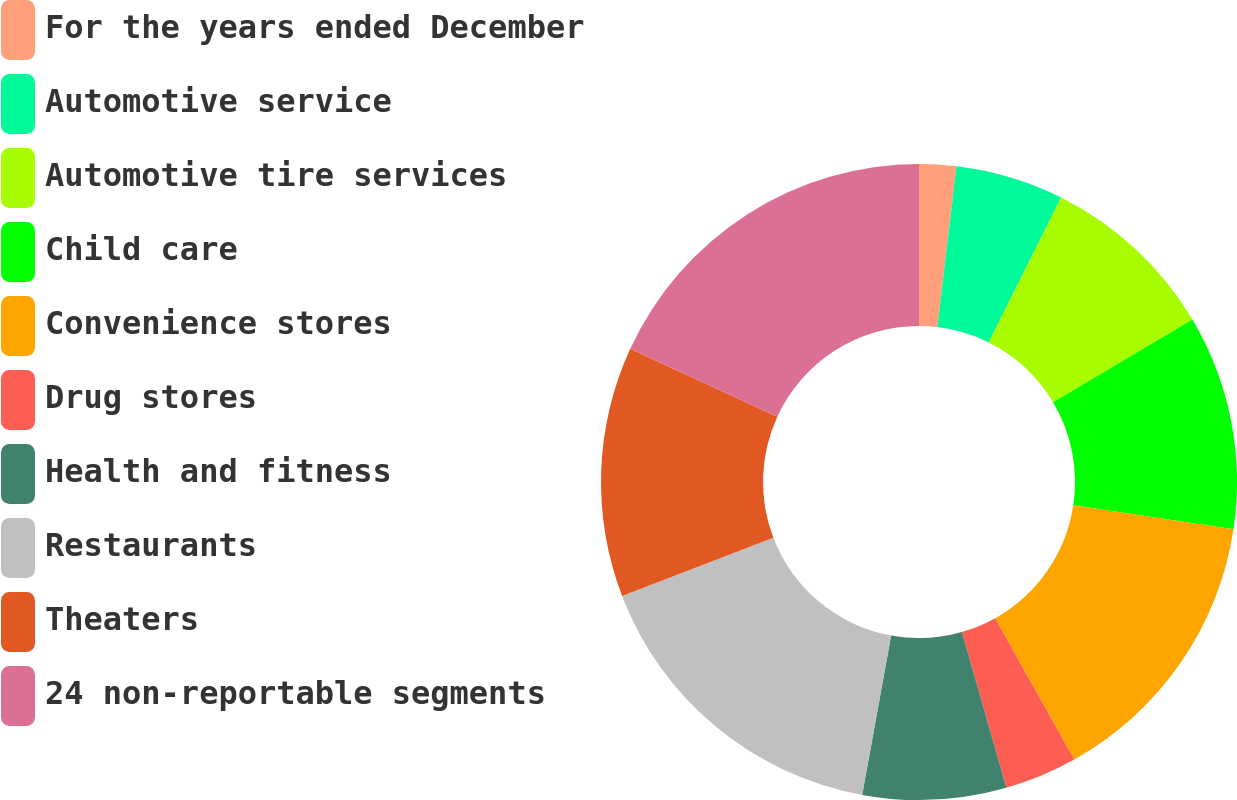Convert chart to OTSL. <chart><loc_0><loc_0><loc_500><loc_500><pie_chart><fcel>For the years ended December<fcel>Automotive service<fcel>Automotive tire services<fcel>Child care<fcel>Convenience stores<fcel>Drug stores<fcel>Health and fitness<fcel>Restaurants<fcel>Theaters<fcel>24 non-reportable segments<nl><fcel>1.88%<fcel>5.49%<fcel>9.1%<fcel>10.9%<fcel>14.51%<fcel>3.69%<fcel>7.29%<fcel>16.31%<fcel>12.71%<fcel>18.12%<nl></chart> 